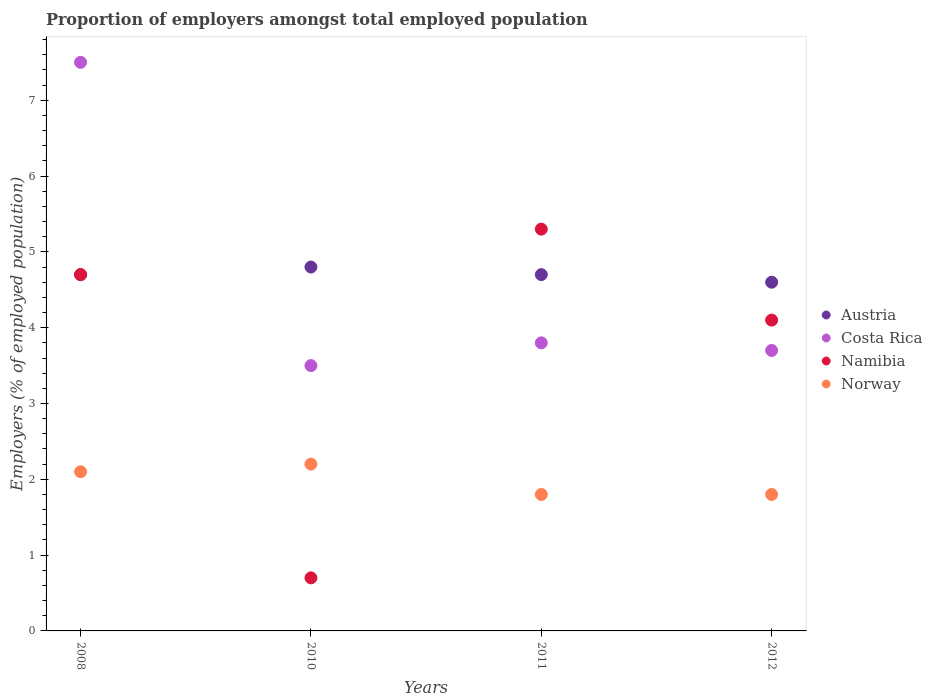How many different coloured dotlines are there?
Your answer should be compact. 4. Is the number of dotlines equal to the number of legend labels?
Offer a very short reply. Yes. What is the proportion of employers in Namibia in 2012?
Offer a terse response. 4.1. Across all years, what is the maximum proportion of employers in Namibia?
Offer a terse response. 5.3. Across all years, what is the minimum proportion of employers in Norway?
Your response must be concise. 1.8. What is the total proportion of employers in Norway in the graph?
Your answer should be compact. 7.9. What is the difference between the proportion of employers in Costa Rica in 2008 and that in 2010?
Provide a short and direct response. 4. What is the average proportion of employers in Namibia per year?
Your answer should be very brief. 3.7. In the year 2011, what is the difference between the proportion of employers in Norway and proportion of employers in Namibia?
Keep it short and to the point. -3.5. In how many years, is the proportion of employers in Austria greater than 2 %?
Give a very brief answer. 4. Is the difference between the proportion of employers in Norway in 2011 and 2012 greater than the difference between the proportion of employers in Namibia in 2011 and 2012?
Make the answer very short. No. What is the difference between the highest and the second highest proportion of employers in Costa Rica?
Make the answer very short. 3.7. What is the difference between the highest and the lowest proportion of employers in Namibia?
Make the answer very short. 4.6. Is it the case that in every year, the sum of the proportion of employers in Austria and proportion of employers in Costa Rica  is greater than the sum of proportion of employers in Namibia and proportion of employers in Norway?
Offer a very short reply. No. Does the proportion of employers in Costa Rica monotonically increase over the years?
Offer a terse response. No. Is the proportion of employers in Namibia strictly greater than the proportion of employers in Norway over the years?
Give a very brief answer. No. Is the proportion of employers in Austria strictly less than the proportion of employers in Costa Rica over the years?
Give a very brief answer. No. How many dotlines are there?
Give a very brief answer. 4. How many years are there in the graph?
Make the answer very short. 4. What is the difference between two consecutive major ticks on the Y-axis?
Offer a terse response. 1. Are the values on the major ticks of Y-axis written in scientific E-notation?
Ensure brevity in your answer.  No. Does the graph contain grids?
Your answer should be compact. No. How many legend labels are there?
Your response must be concise. 4. How are the legend labels stacked?
Provide a short and direct response. Vertical. What is the title of the graph?
Provide a succinct answer. Proportion of employers amongst total employed population. Does "Sub-Saharan Africa (developing only)" appear as one of the legend labels in the graph?
Make the answer very short. No. What is the label or title of the Y-axis?
Provide a short and direct response. Employers (% of employed population). What is the Employers (% of employed population) of Austria in 2008?
Provide a short and direct response. 4.7. What is the Employers (% of employed population) in Costa Rica in 2008?
Your response must be concise. 7.5. What is the Employers (% of employed population) in Namibia in 2008?
Keep it short and to the point. 4.7. What is the Employers (% of employed population) of Norway in 2008?
Give a very brief answer. 2.1. What is the Employers (% of employed population) in Austria in 2010?
Give a very brief answer. 4.8. What is the Employers (% of employed population) in Costa Rica in 2010?
Provide a succinct answer. 3.5. What is the Employers (% of employed population) of Namibia in 2010?
Offer a terse response. 0.7. What is the Employers (% of employed population) of Norway in 2010?
Your answer should be very brief. 2.2. What is the Employers (% of employed population) in Austria in 2011?
Provide a short and direct response. 4.7. What is the Employers (% of employed population) in Costa Rica in 2011?
Keep it short and to the point. 3.8. What is the Employers (% of employed population) of Namibia in 2011?
Your answer should be compact. 5.3. What is the Employers (% of employed population) of Norway in 2011?
Your answer should be very brief. 1.8. What is the Employers (% of employed population) in Austria in 2012?
Your answer should be compact. 4.6. What is the Employers (% of employed population) in Costa Rica in 2012?
Your response must be concise. 3.7. What is the Employers (% of employed population) of Namibia in 2012?
Your answer should be very brief. 4.1. What is the Employers (% of employed population) in Norway in 2012?
Keep it short and to the point. 1.8. Across all years, what is the maximum Employers (% of employed population) in Austria?
Make the answer very short. 4.8. Across all years, what is the maximum Employers (% of employed population) in Costa Rica?
Offer a terse response. 7.5. Across all years, what is the maximum Employers (% of employed population) in Namibia?
Offer a terse response. 5.3. Across all years, what is the maximum Employers (% of employed population) in Norway?
Provide a short and direct response. 2.2. Across all years, what is the minimum Employers (% of employed population) in Austria?
Offer a terse response. 4.6. Across all years, what is the minimum Employers (% of employed population) in Costa Rica?
Give a very brief answer. 3.5. Across all years, what is the minimum Employers (% of employed population) in Namibia?
Ensure brevity in your answer.  0.7. Across all years, what is the minimum Employers (% of employed population) of Norway?
Your answer should be compact. 1.8. What is the total Employers (% of employed population) of Austria in the graph?
Provide a succinct answer. 18.8. What is the difference between the Employers (% of employed population) of Austria in 2008 and that in 2010?
Provide a succinct answer. -0.1. What is the difference between the Employers (% of employed population) of Austria in 2008 and that in 2011?
Give a very brief answer. 0. What is the difference between the Employers (% of employed population) of Costa Rica in 2008 and that in 2011?
Offer a very short reply. 3.7. What is the difference between the Employers (% of employed population) of Namibia in 2008 and that in 2011?
Your answer should be very brief. -0.6. What is the difference between the Employers (% of employed population) of Namibia in 2008 and that in 2012?
Give a very brief answer. 0.6. What is the difference between the Employers (% of employed population) of Costa Rica in 2010 and that in 2011?
Provide a short and direct response. -0.3. What is the difference between the Employers (% of employed population) of Namibia in 2010 and that in 2012?
Your answer should be compact. -3.4. What is the difference between the Employers (% of employed population) in Namibia in 2011 and that in 2012?
Provide a succinct answer. 1.2. What is the difference between the Employers (% of employed population) in Norway in 2011 and that in 2012?
Offer a very short reply. 0. What is the difference between the Employers (% of employed population) of Austria in 2008 and the Employers (% of employed population) of Costa Rica in 2010?
Make the answer very short. 1.2. What is the difference between the Employers (% of employed population) in Austria in 2008 and the Employers (% of employed population) in Norway in 2010?
Keep it short and to the point. 2.5. What is the difference between the Employers (% of employed population) in Costa Rica in 2008 and the Employers (% of employed population) in Norway in 2010?
Ensure brevity in your answer.  5.3. What is the difference between the Employers (% of employed population) in Austria in 2008 and the Employers (% of employed population) in Costa Rica in 2011?
Offer a terse response. 0.9. What is the difference between the Employers (% of employed population) of Austria in 2008 and the Employers (% of employed population) of Norway in 2011?
Offer a terse response. 2.9. What is the difference between the Employers (% of employed population) of Costa Rica in 2008 and the Employers (% of employed population) of Namibia in 2011?
Provide a succinct answer. 2.2. What is the difference between the Employers (% of employed population) of Costa Rica in 2008 and the Employers (% of employed population) of Norway in 2011?
Keep it short and to the point. 5.7. What is the difference between the Employers (% of employed population) in Costa Rica in 2008 and the Employers (% of employed population) in Norway in 2012?
Make the answer very short. 5.7. What is the difference between the Employers (% of employed population) in Austria in 2010 and the Employers (% of employed population) in Norway in 2011?
Offer a very short reply. 3. What is the difference between the Employers (% of employed population) of Costa Rica in 2010 and the Employers (% of employed population) of Namibia in 2011?
Offer a terse response. -1.8. What is the difference between the Employers (% of employed population) of Austria in 2010 and the Employers (% of employed population) of Norway in 2012?
Offer a terse response. 3. What is the difference between the Employers (% of employed population) of Costa Rica in 2010 and the Employers (% of employed population) of Norway in 2012?
Keep it short and to the point. 1.7. What is the difference between the Employers (% of employed population) in Namibia in 2010 and the Employers (% of employed population) in Norway in 2012?
Provide a short and direct response. -1.1. What is the difference between the Employers (% of employed population) of Costa Rica in 2011 and the Employers (% of employed population) of Namibia in 2012?
Your answer should be very brief. -0.3. What is the difference between the Employers (% of employed population) in Costa Rica in 2011 and the Employers (% of employed population) in Norway in 2012?
Your answer should be compact. 2. What is the average Employers (% of employed population) in Austria per year?
Provide a short and direct response. 4.7. What is the average Employers (% of employed population) in Costa Rica per year?
Provide a succinct answer. 4.62. What is the average Employers (% of employed population) in Norway per year?
Your answer should be compact. 1.98. In the year 2008, what is the difference between the Employers (% of employed population) of Costa Rica and Employers (% of employed population) of Namibia?
Offer a very short reply. 2.8. In the year 2008, what is the difference between the Employers (% of employed population) of Namibia and Employers (% of employed population) of Norway?
Provide a succinct answer. 2.6. In the year 2010, what is the difference between the Employers (% of employed population) in Austria and Employers (% of employed population) in Costa Rica?
Provide a short and direct response. 1.3. In the year 2010, what is the difference between the Employers (% of employed population) of Austria and Employers (% of employed population) of Namibia?
Ensure brevity in your answer.  4.1. In the year 2010, what is the difference between the Employers (% of employed population) of Costa Rica and Employers (% of employed population) of Namibia?
Give a very brief answer. 2.8. In the year 2010, what is the difference between the Employers (% of employed population) of Namibia and Employers (% of employed population) of Norway?
Keep it short and to the point. -1.5. In the year 2011, what is the difference between the Employers (% of employed population) of Austria and Employers (% of employed population) of Norway?
Make the answer very short. 2.9. In the year 2011, what is the difference between the Employers (% of employed population) of Costa Rica and Employers (% of employed population) of Namibia?
Your answer should be very brief. -1.5. In the year 2011, what is the difference between the Employers (% of employed population) in Namibia and Employers (% of employed population) in Norway?
Give a very brief answer. 3.5. In the year 2012, what is the difference between the Employers (% of employed population) in Austria and Employers (% of employed population) in Costa Rica?
Provide a short and direct response. 0.9. What is the ratio of the Employers (% of employed population) in Austria in 2008 to that in 2010?
Keep it short and to the point. 0.98. What is the ratio of the Employers (% of employed population) of Costa Rica in 2008 to that in 2010?
Provide a short and direct response. 2.14. What is the ratio of the Employers (% of employed population) of Namibia in 2008 to that in 2010?
Keep it short and to the point. 6.71. What is the ratio of the Employers (% of employed population) in Norway in 2008 to that in 2010?
Provide a succinct answer. 0.95. What is the ratio of the Employers (% of employed population) in Costa Rica in 2008 to that in 2011?
Give a very brief answer. 1.97. What is the ratio of the Employers (% of employed population) in Namibia in 2008 to that in 2011?
Your answer should be compact. 0.89. What is the ratio of the Employers (% of employed population) of Norway in 2008 to that in 2011?
Provide a succinct answer. 1.17. What is the ratio of the Employers (% of employed population) in Austria in 2008 to that in 2012?
Ensure brevity in your answer.  1.02. What is the ratio of the Employers (% of employed population) in Costa Rica in 2008 to that in 2012?
Give a very brief answer. 2.03. What is the ratio of the Employers (% of employed population) in Namibia in 2008 to that in 2012?
Offer a terse response. 1.15. What is the ratio of the Employers (% of employed population) in Norway in 2008 to that in 2012?
Keep it short and to the point. 1.17. What is the ratio of the Employers (% of employed population) of Austria in 2010 to that in 2011?
Offer a terse response. 1.02. What is the ratio of the Employers (% of employed population) in Costa Rica in 2010 to that in 2011?
Your answer should be compact. 0.92. What is the ratio of the Employers (% of employed population) of Namibia in 2010 to that in 2011?
Give a very brief answer. 0.13. What is the ratio of the Employers (% of employed population) in Norway in 2010 to that in 2011?
Offer a very short reply. 1.22. What is the ratio of the Employers (% of employed population) in Austria in 2010 to that in 2012?
Give a very brief answer. 1.04. What is the ratio of the Employers (% of employed population) in Costa Rica in 2010 to that in 2012?
Provide a short and direct response. 0.95. What is the ratio of the Employers (% of employed population) in Namibia in 2010 to that in 2012?
Offer a terse response. 0.17. What is the ratio of the Employers (% of employed population) of Norway in 2010 to that in 2012?
Give a very brief answer. 1.22. What is the ratio of the Employers (% of employed population) of Austria in 2011 to that in 2012?
Offer a terse response. 1.02. What is the ratio of the Employers (% of employed population) of Namibia in 2011 to that in 2012?
Make the answer very short. 1.29. What is the difference between the highest and the second highest Employers (% of employed population) in Austria?
Provide a short and direct response. 0.1. What is the difference between the highest and the second highest Employers (% of employed population) of Norway?
Your answer should be very brief. 0.1. What is the difference between the highest and the lowest Employers (% of employed population) of Costa Rica?
Provide a short and direct response. 4. What is the difference between the highest and the lowest Employers (% of employed population) of Namibia?
Your answer should be very brief. 4.6. 